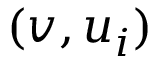<formula> <loc_0><loc_0><loc_500><loc_500>( v , u _ { i } )</formula> 